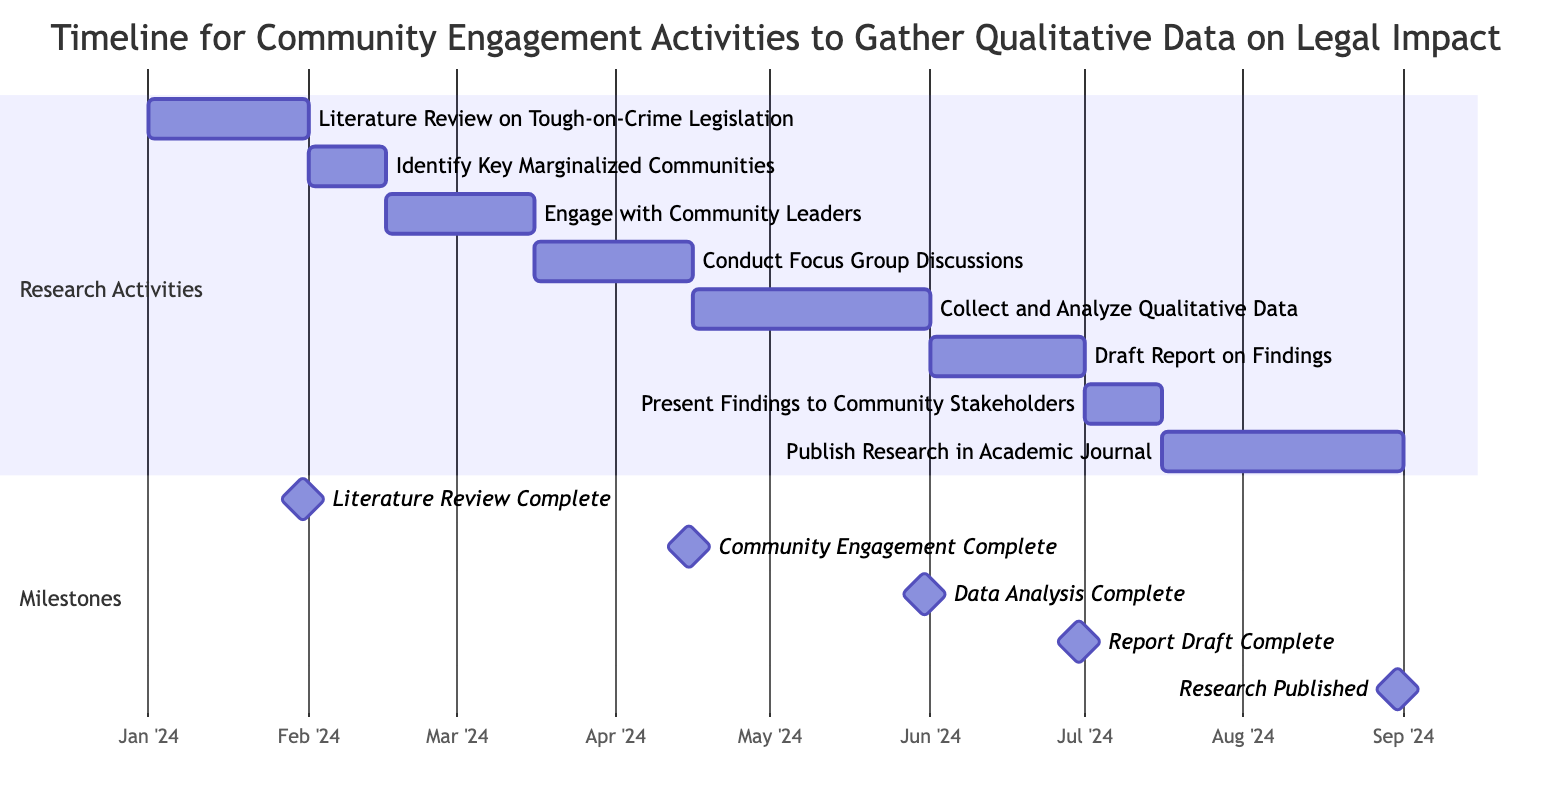What is the duration of the "Engage with Community Leaders" task? The "Engage with Community Leaders" task starts on February 16, 2024, and ends on March 15, 2024. This is a period of 29 days.
Answer: 29 days When does the "Draft Report on Findings" start? The task "Draft Report on Findings" begins on June 1, 2024, as indicated on the Gantt chart.
Answer: June 1, 2024 How many tasks are scheduled to occur in March 2024? In March 2024, two tasks are scheduled: "Engage with Community Leaders" and "Conduct Focus Group Discussions."
Answer: 2 tasks What milestone occurs after the completion of "Collect and Analyze Qualitative Data"? The milestone that occurs after "Collect and Analyze Qualitative Data" is the "Data Analysis Complete" milestone, which is scheduled for May 31, 2024.
Answer: Data Analysis Complete Which task spans the longest duration? The task "Collect and Analyze Qualitative Data" spans 46 days, making it the task with the longest duration in this timeline.
Answer: Collect and Analyze Qualitative Data What is the end date for the "Publish Research in Academic Journal" task? The "Publish Research in Academic Journal" task ends on August 31, 2024, which marks its completion.
Answer: August 31, 2024 Which two tasks have overlapping timelines? The tasks "Conduct Focus Group Discussions" and "Collect and Analyze Qualitative Data" have overlapping timelines, as the first ends on April 15, 2024, and the latter starts on April 16, 2024.
Answer: Conduct Focus Group Discussions and Collect and Analyze Qualitative Data How many days are between the completion of the "Literature Review" and the start of the "Identify Key Marginalized Communities"? The "Literature Review" completes on January 31, 2024, and "Identify Key Marginalized Communities" starts on February 1, 2024, resulting in a gap of 0 days.
Answer: 0 days 